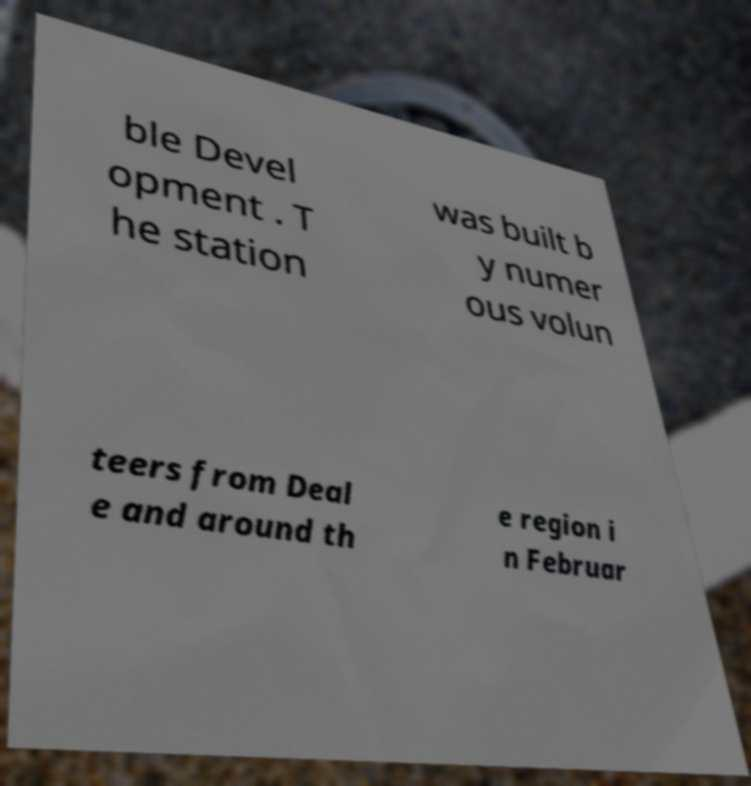There's text embedded in this image that I need extracted. Can you transcribe it verbatim? ble Devel opment . T he station was built b y numer ous volun teers from Deal e and around th e region i n Februar 